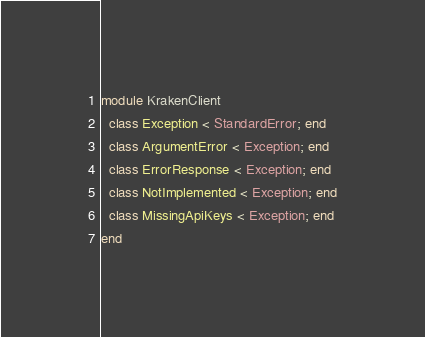Convert code to text. <code><loc_0><loc_0><loc_500><loc_500><_Ruby_>module KrakenClient
  class Exception < StandardError; end
  class ArgumentError < Exception; end
  class ErrorResponse < Exception; end
  class NotImplemented < Exception; end
  class MissingApiKeys < Exception; end
end
</code> 